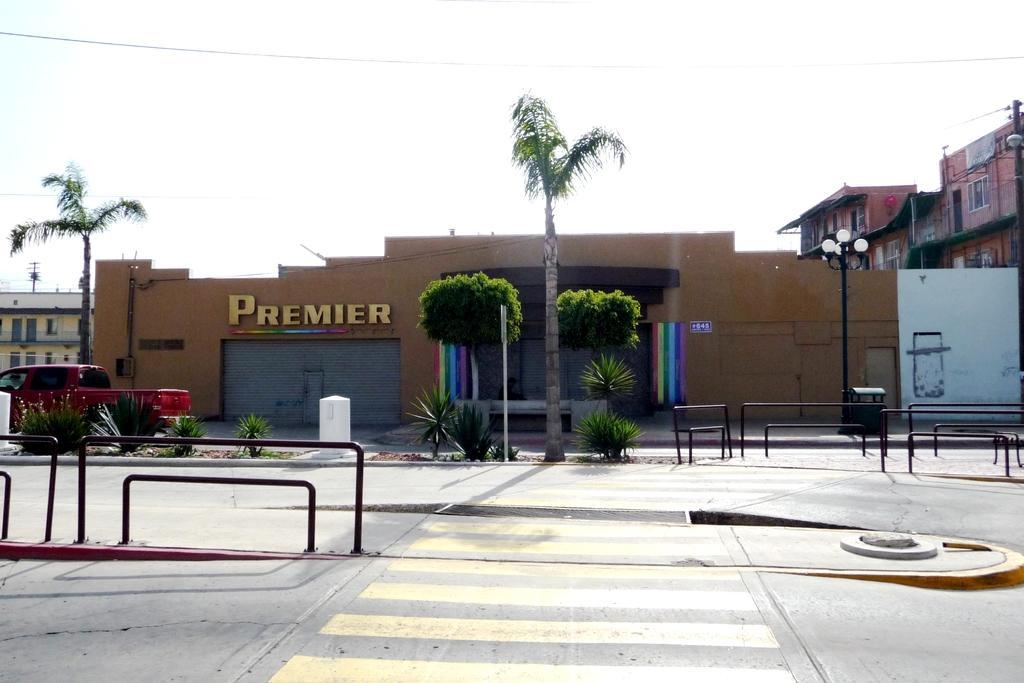Can you describe this image briefly? In the center of the image there is road. There are barrier gates. In the background of the image there is building. There are trees. There is a vehicle on the road. 